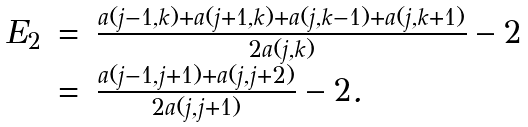Convert formula to latex. <formula><loc_0><loc_0><loc_500><loc_500>\begin{array} { l l l } E _ { 2 } & = & \frac { a ( j - 1 , k ) + a ( j + 1 , k ) + a ( j , k - 1 ) + a ( j , k + 1 ) } { 2 a ( j , k ) } - 2 \\ & = & \frac { a ( j - 1 , j + 1 ) + a ( j , j + 2 ) } { 2 a ( j , j + 1 ) } - 2 . \end{array}</formula> 